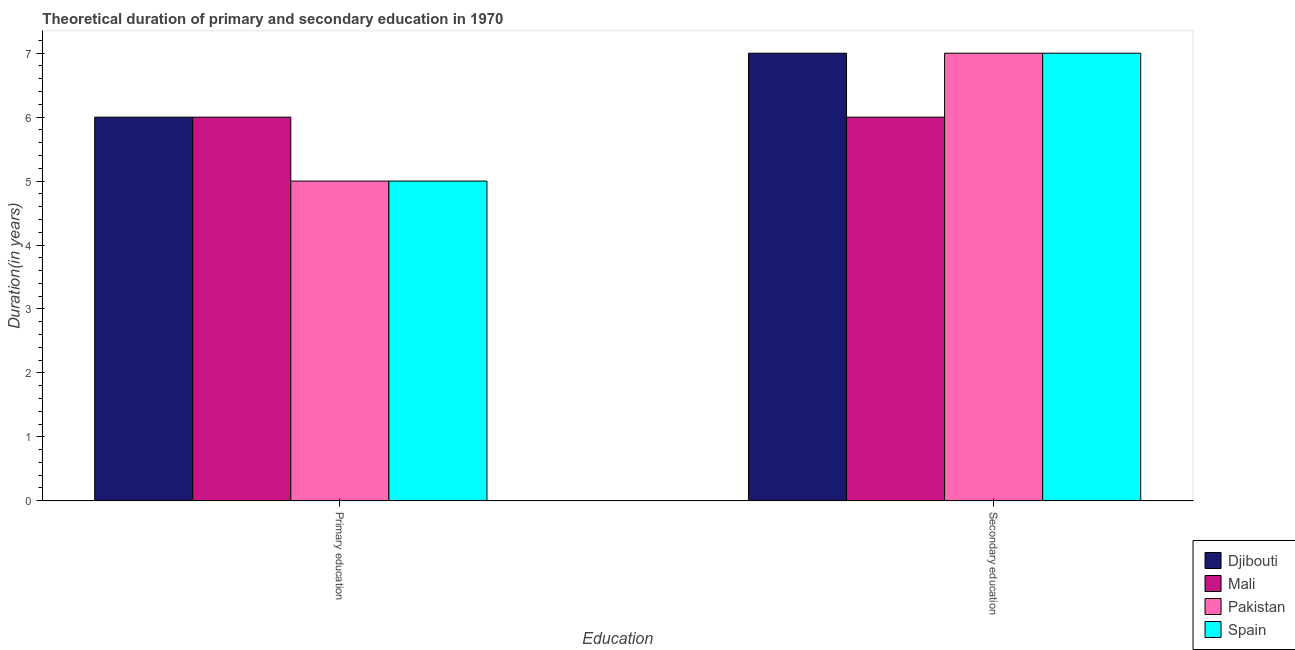How many groups of bars are there?
Keep it short and to the point. 2. Are the number of bars per tick equal to the number of legend labels?
Offer a very short reply. Yes. What is the label of the 2nd group of bars from the left?
Provide a short and direct response. Secondary education. What is the duration of secondary education in Spain?
Ensure brevity in your answer.  7. Across all countries, what is the maximum duration of secondary education?
Offer a very short reply. 7. Across all countries, what is the minimum duration of primary education?
Offer a very short reply. 5. In which country was the duration of secondary education maximum?
Give a very brief answer. Djibouti. What is the total duration of primary education in the graph?
Provide a succinct answer. 22. What is the difference between the duration of secondary education in Pakistan and that in Mali?
Ensure brevity in your answer.  1. What is the difference between the duration of secondary education in Pakistan and the duration of primary education in Spain?
Your answer should be compact. 2. What is the average duration of secondary education per country?
Ensure brevity in your answer.  6.75. What is the difference between the duration of primary education and duration of secondary education in Mali?
Offer a very short reply. 0. In how many countries, is the duration of secondary education greater than 2 years?
Make the answer very short. 4. What is the ratio of the duration of primary education in Pakistan to that in Djibouti?
Your answer should be very brief. 0.83. In how many countries, is the duration of primary education greater than the average duration of primary education taken over all countries?
Your response must be concise. 2. What does the 4th bar from the left in Secondary education represents?
Your response must be concise. Spain. What does the 1st bar from the right in Secondary education represents?
Provide a short and direct response. Spain. How many bars are there?
Your response must be concise. 8. Are all the bars in the graph horizontal?
Keep it short and to the point. No. How many countries are there in the graph?
Your answer should be very brief. 4. Where does the legend appear in the graph?
Give a very brief answer. Bottom right. How many legend labels are there?
Keep it short and to the point. 4. What is the title of the graph?
Your answer should be very brief. Theoretical duration of primary and secondary education in 1970. Does "Tanzania" appear as one of the legend labels in the graph?
Your response must be concise. No. What is the label or title of the X-axis?
Make the answer very short. Education. What is the label or title of the Y-axis?
Make the answer very short. Duration(in years). What is the Duration(in years) of Djibouti in Primary education?
Provide a short and direct response. 6. What is the Duration(in years) of Mali in Primary education?
Offer a very short reply. 6. What is the Duration(in years) of Pakistan in Primary education?
Make the answer very short. 5. What is the Duration(in years) of Spain in Primary education?
Your answer should be compact. 5. What is the Duration(in years) of Mali in Secondary education?
Ensure brevity in your answer.  6. What is the Duration(in years) of Pakistan in Secondary education?
Offer a terse response. 7. Across all Education, what is the maximum Duration(in years) in Mali?
Provide a succinct answer. 6. Across all Education, what is the maximum Duration(in years) in Spain?
Offer a very short reply. 7. Across all Education, what is the minimum Duration(in years) in Mali?
Your response must be concise. 6. Across all Education, what is the minimum Duration(in years) of Spain?
Provide a short and direct response. 5. What is the total Duration(in years) in Mali in the graph?
Your response must be concise. 12. What is the difference between the Duration(in years) in Pakistan in Primary education and that in Secondary education?
Your answer should be very brief. -2. What is the difference between the Duration(in years) in Djibouti in Primary education and the Duration(in years) in Mali in Secondary education?
Your response must be concise. 0. What is the difference between the Duration(in years) in Djibouti in Primary education and the Duration(in years) in Spain in Secondary education?
Make the answer very short. -1. What is the difference between the Duration(in years) in Mali in Primary education and the Duration(in years) in Spain in Secondary education?
Ensure brevity in your answer.  -1. What is the average Duration(in years) of Spain per Education?
Ensure brevity in your answer.  6. What is the difference between the Duration(in years) in Djibouti and Duration(in years) in Spain in Primary education?
Your response must be concise. 1. What is the difference between the Duration(in years) of Djibouti and Duration(in years) of Spain in Secondary education?
Offer a very short reply. 0. What is the difference between the Duration(in years) of Pakistan and Duration(in years) of Spain in Secondary education?
Keep it short and to the point. 0. What is the ratio of the Duration(in years) in Djibouti in Primary education to that in Secondary education?
Keep it short and to the point. 0.86. What is the ratio of the Duration(in years) in Mali in Primary education to that in Secondary education?
Your answer should be compact. 1. What is the difference between the highest and the second highest Duration(in years) of Pakistan?
Provide a short and direct response. 2. What is the difference between the highest and the second highest Duration(in years) of Spain?
Provide a succinct answer. 2. What is the difference between the highest and the lowest Duration(in years) in Pakistan?
Give a very brief answer. 2. What is the difference between the highest and the lowest Duration(in years) in Spain?
Your answer should be compact. 2. 